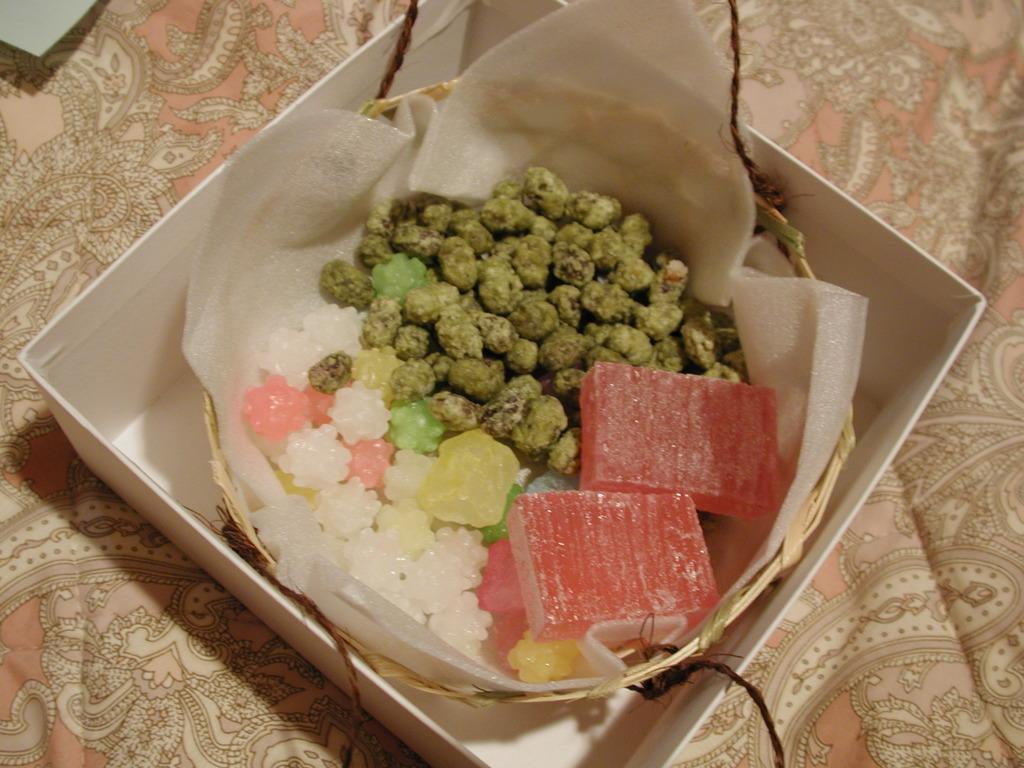Can you describe this image briefly? In the picture we can see the box inside it, we can see the bowl with a food item. 